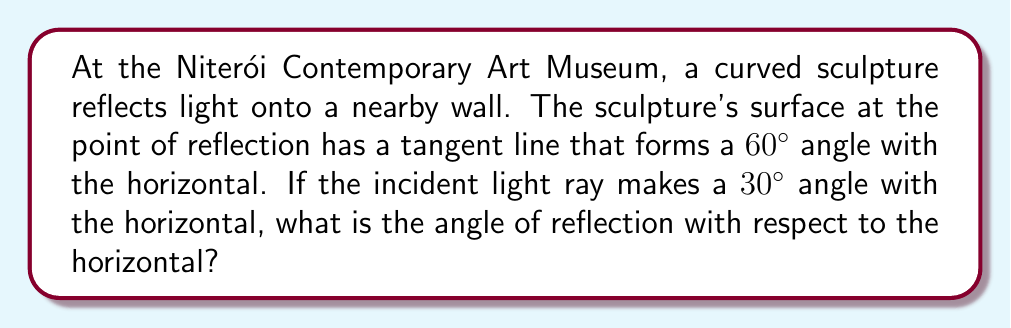Help me with this question. Let's approach this step-by-step:

1) First, recall the law of reflection: the angle of incidence equals the angle of reflection with respect to the normal line (perpendicular to the surface).

2) We need to find the normal line to the surface. Since the tangent line makes a 60° angle with the horizontal, the normal line will be perpendicular to this, making a 30° angle with the horizontal.

3) Let's define our angles:
   - $\theta_i$ = angle of incidence with respect to the normal
   - $\theta_r$ = angle of reflection with respect to the normal
   - $\alpha$ = angle we're looking for (reflection with respect to horizontal)

4) We know the incident ray makes a 30° angle with the horizontal, and the normal makes a 30° angle with the horizontal in the opposite direction. So:

   $\theta_i = 30° + 30° = 60°$

5) By the law of reflection:

   $\theta_r = \theta_i = 60°$

6) Now, to find $\alpha$, we subtract the angle of the normal from $\theta_r$:

   $\alpha = \theta_r - 30° = 60° - 30° = 30°$

Therefore, the angle of reflection with respect to the horizontal is 30°.
Answer: 30° 